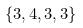Convert formula to latex. <formula><loc_0><loc_0><loc_500><loc_500>\{ 3 , 4 , 3 , 3 \}</formula> 